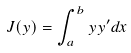Convert formula to latex. <formula><loc_0><loc_0><loc_500><loc_500>J ( y ) = \int _ { a } ^ { b } y y ^ { \prime } d x</formula> 